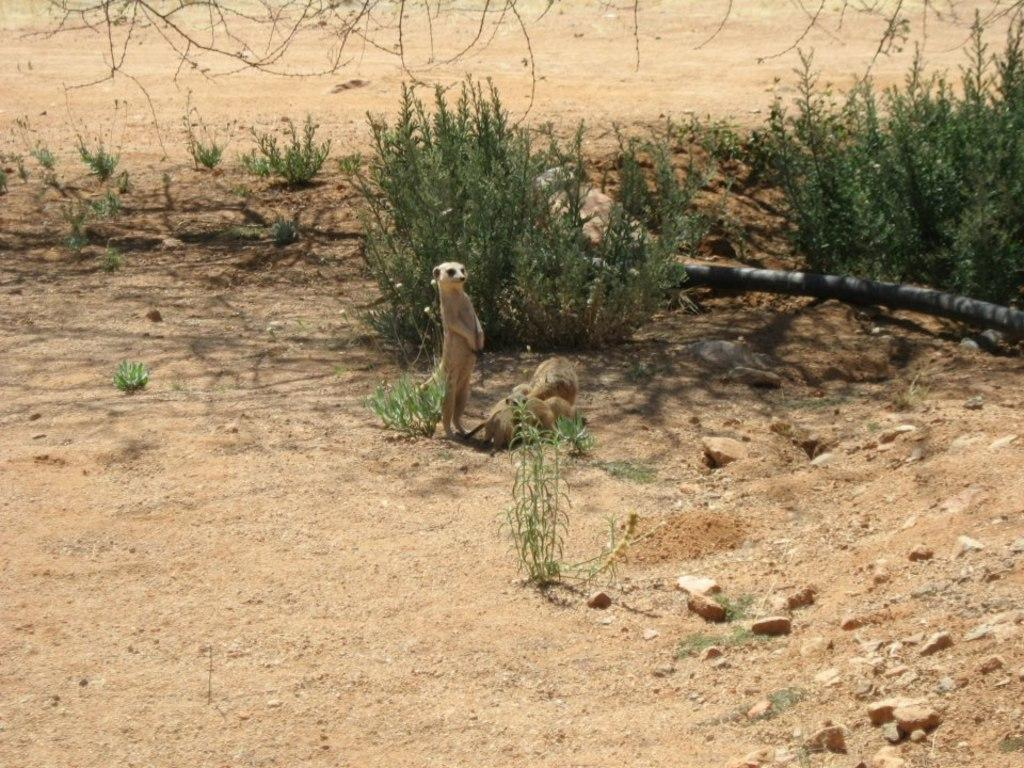What is the primary surface visible in the image? There is a ground in the image. What type of living organisms can be seen on the ground? There are animals on the ground. What can be seen in the background behind the animals? There are small plants visible behind the animals. What type of blood can be seen flowing from the animals in the image? There is no blood visible in the image; the animals are not injured or bleeding. 